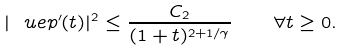<formula> <loc_0><loc_0><loc_500><loc_500>| \ u e p ^ { \prime } ( t ) | ^ { 2 } \leq \frac { C _ { 2 } } { ( 1 + t ) ^ { 2 + 1 / \gamma } } \quad \forall t \geq 0 .</formula> 